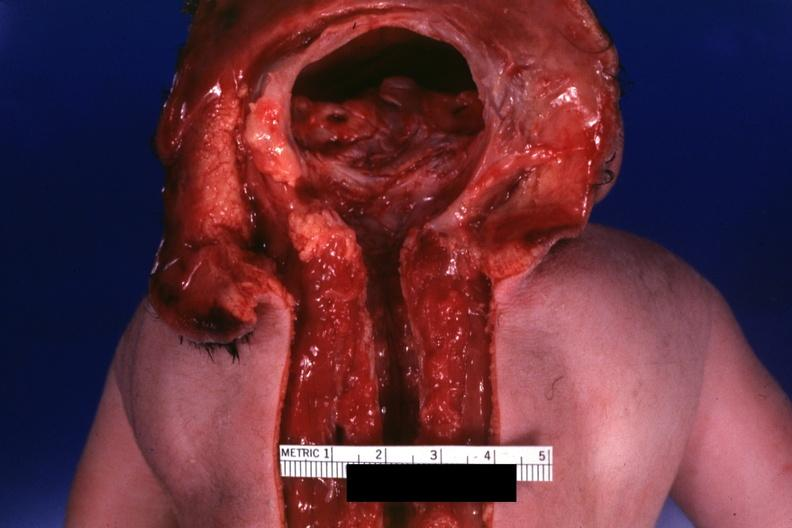what lived one day?
Answer the question using a single word or phrase. No chromosomal defects 